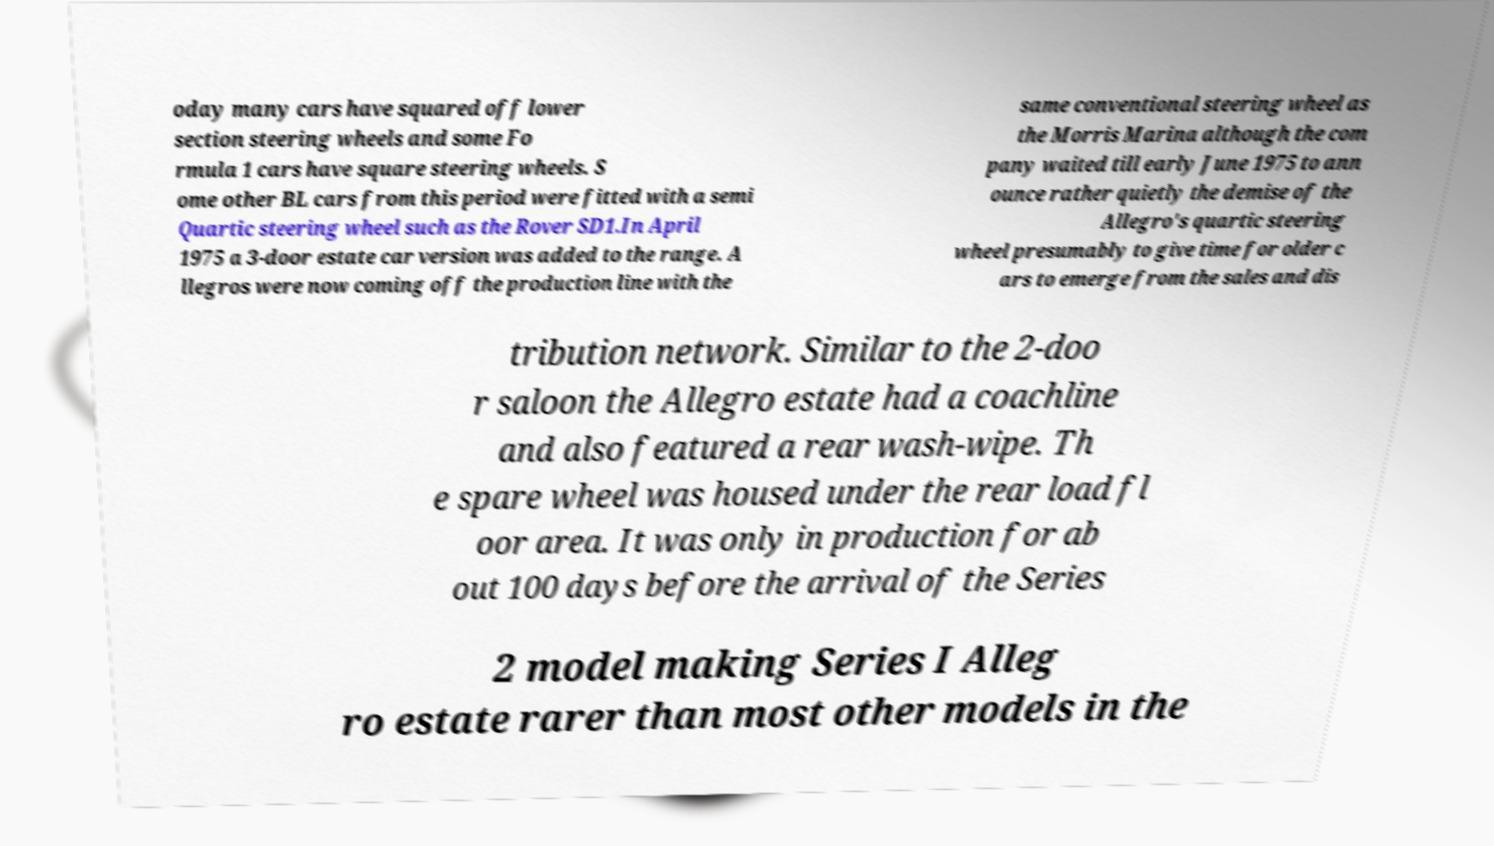I need the written content from this picture converted into text. Can you do that? oday many cars have squared off lower section steering wheels and some Fo rmula 1 cars have square steering wheels. S ome other BL cars from this period were fitted with a semi Quartic steering wheel such as the Rover SD1.In April 1975 a 3-door estate car version was added to the range. A llegros were now coming off the production line with the same conventional steering wheel as the Morris Marina although the com pany waited till early June 1975 to ann ounce rather quietly the demise of the Allegro's quartic steering wheel presumably to give time for older c ars to emerge from the sales and dis tribution network. Similar to the 2-doo r saloon the Allegro estate had a coachline and also featured a rear wash-wipe. Th e spare wheel was housed under the rear load fl oor area. It was only in production for ab out 100 days before the arrival of the Series 2 model making Series I Alleg ro estate rarer than most other models in the 